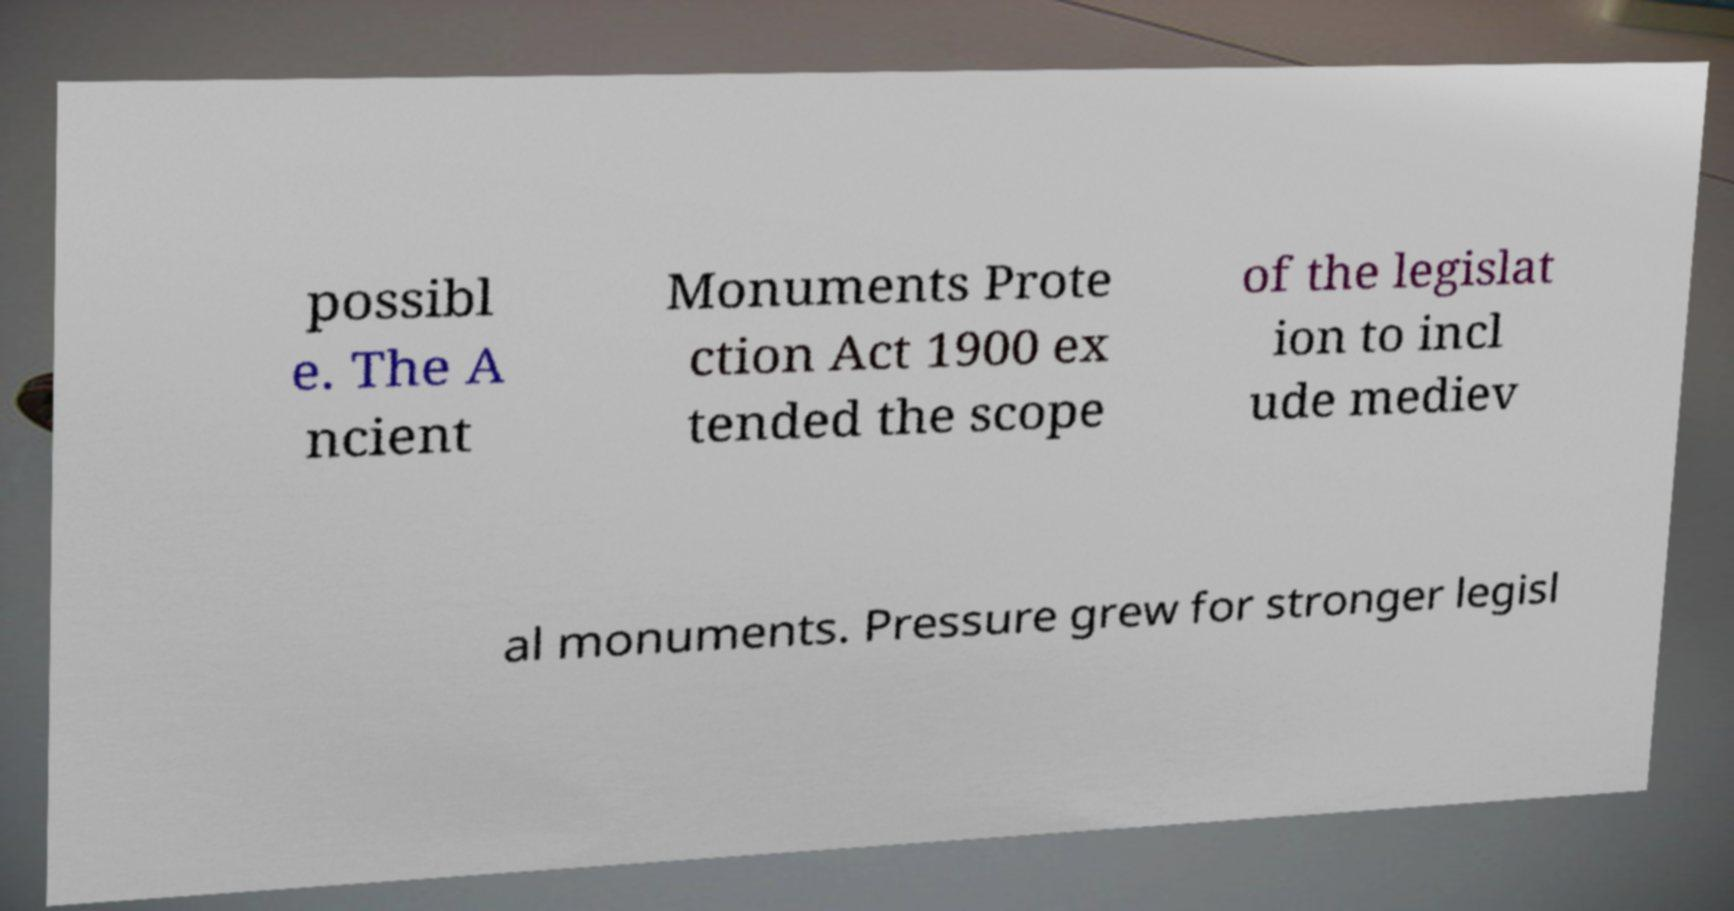Please identify and transcribe the text found in this image. possibl e. The A ncient Monuments Prote ction Act 1900 ex tended the scope of the legislat ion to incl ude mediev al monuments. Pressure grew for stronger legisl 